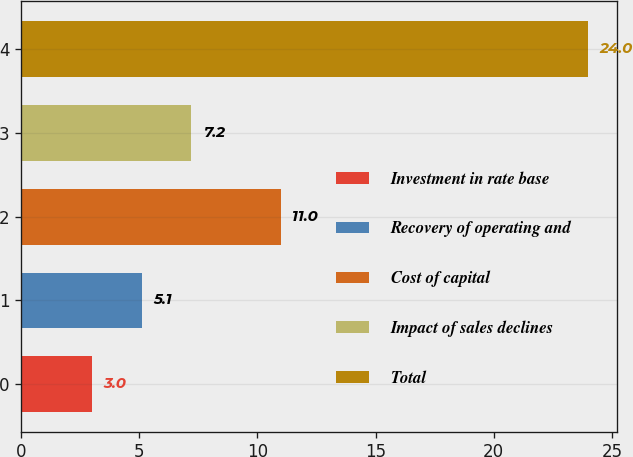Convert chart to OTSL. <chart><loc_0><loc_0><loc_500><loc_500><bar_chart><fcel>Investment in rate base<fcel>Recovery of operating and<fcel>Cost of capital<fcel>Impact of sales declines<fcel>Total<nl><fcel>3<fcel>5.1<fcel>11<fcel>7.2<fcel>24<nl></chart> 